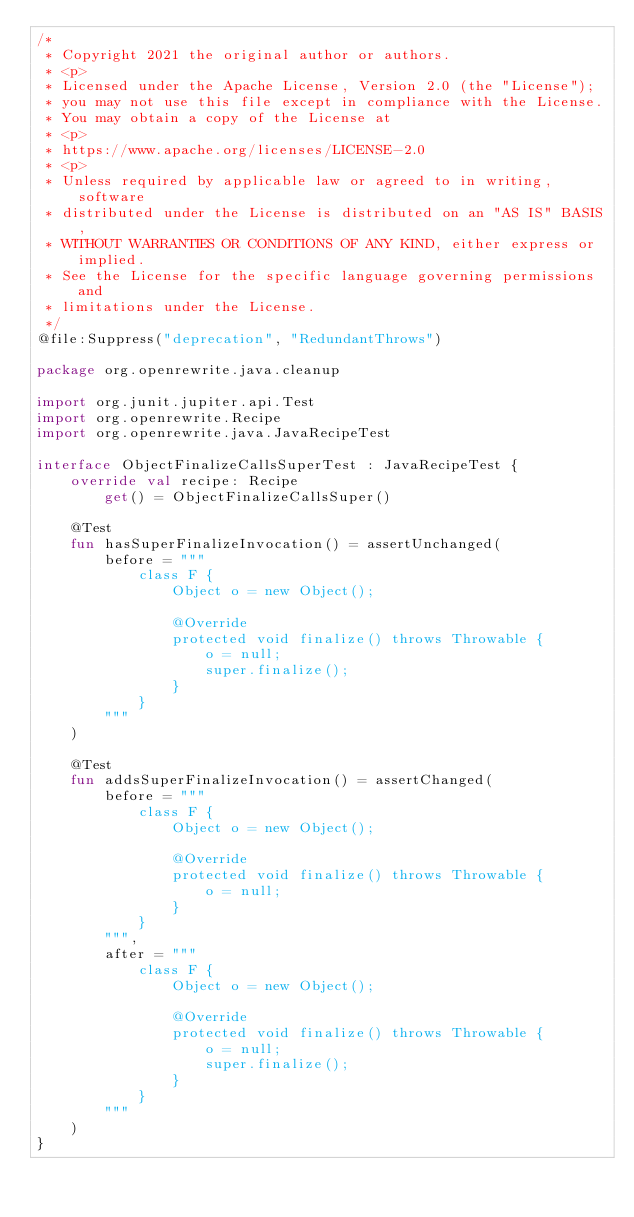<code> <loc_0><loc_0><loc_500><loc_500><_Kotlin_>/*
 * Copyright 2021 the original author or authors.
 * <p>
 * Licensed under the Apache License, Version 2.0 (the "License");
 * you may not use this file except in compliance with the License.
 * You may obtain a copy of the License at
 * <p>
 * https://www.apache.org/licenses/LICENSE-2.0
 * <p>
 * Unless required by applicable law or agreed to in writing, software
 * distributed under the License is distributed on an "AS IS" BASIS,
 * WITHOUT WARRANTIES OR CONDITIONS OF ANY KIND, either express or implied.
 * See the License for the specific language governing permissions and
 * limitations under the License.
 */
@file:Suppress("deprecation", "RedundantThrows")

package org.openrewrite.java.cleanup

import org.junit.jupiter.api.Test
import org.openrewrite.Recipe
import org.openrewrite.java.JavaRecipeTest

interface ObjectFinalizeCallsSuperTest : JavaRecipeTest {
    override val recipe: Recipe
        get() = ObjectFinalizeCallsSuper()

    @Test
    fun hasSuperFinalizeInvocation() = assertUnchanged(
        before = """
            class F {
                Object o = new Object();
                
                @Override
                protected void finalize() throws Throwable {
                    o = null;
                    super.finalize();
                }
            }
        """
    )

    @Test
    fun addsSuperFinalizeInvocation() = assertChanged(
        before = """
            class F {
                Object o = new Object();
                
                @Override
                protected void finalize() throws Throwable {
                    o = null;
                }
            }
        """,
        after = """
            class F {
                Object o = new Object();
                
                @Override
                protected void finalize() throws Throwable {
                    o = null;
                    super.finalize();
                }
            }
        """
    )
}
</code> 